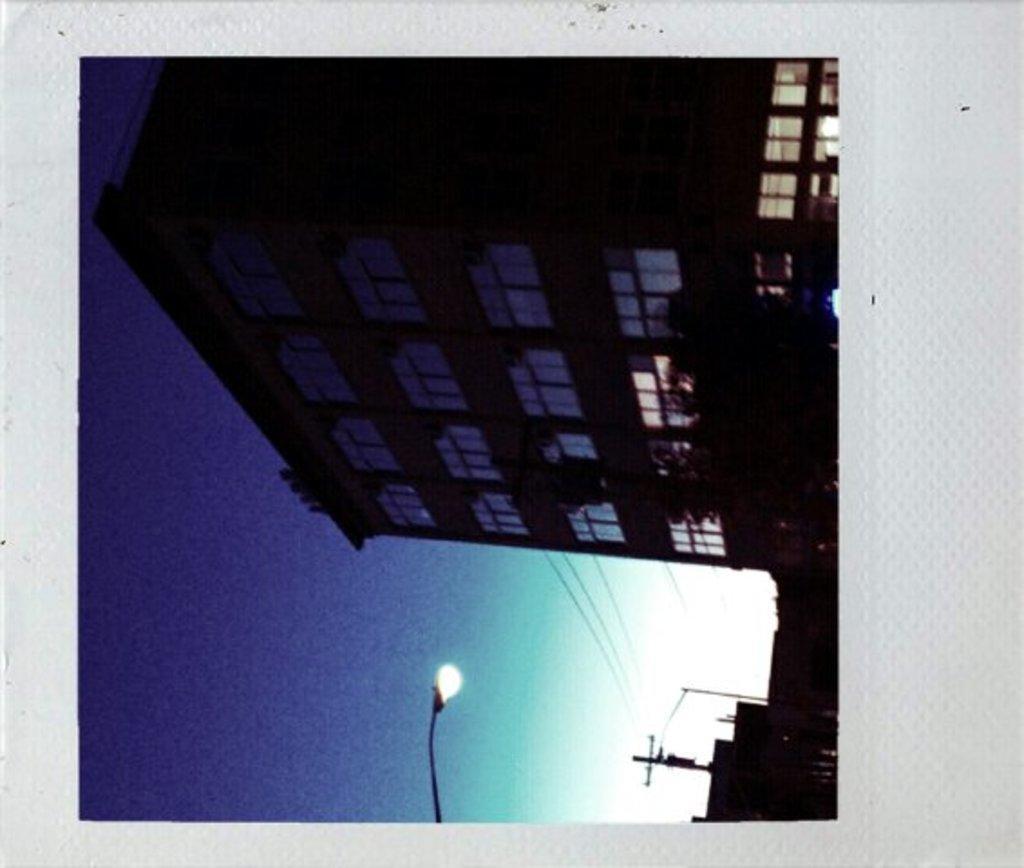Please provide a concise description of this image. In this picture I can see there is a building and there is a electricity pole and there is a street light pole and the sky is clear. 